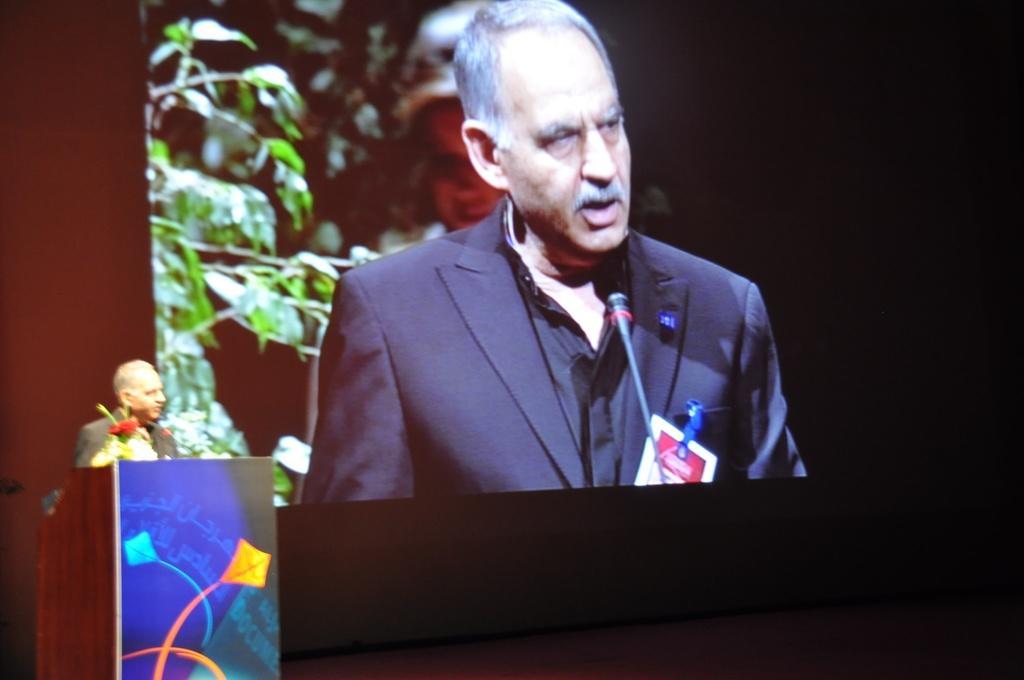How would you summarize this image in a sentence or two? In this picture there is a man standing behind the podium is talking and there is a bouquet on the podium. At the back there is a screen, on the screen there is a picture of a person standing and talking and there is a plant. 